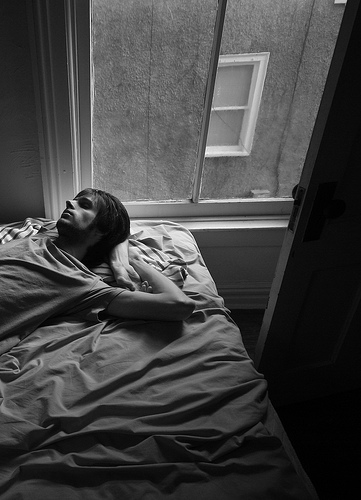What realistic scenario could you imagine that involves the person on the bed and the open window? A realistic scenario could be that the person on the bed is enjoying a lazy Sunday morning. They have no immediate tasks to attend to, so they are simply enjoying the peacefulness of the moment, allowing their mind to wander as they gaze outside the open window. The subtle sound of the outside world provides a calming backdrop, making them feel connected yet comfortably distant from the hustle and bustle of everyday life. 